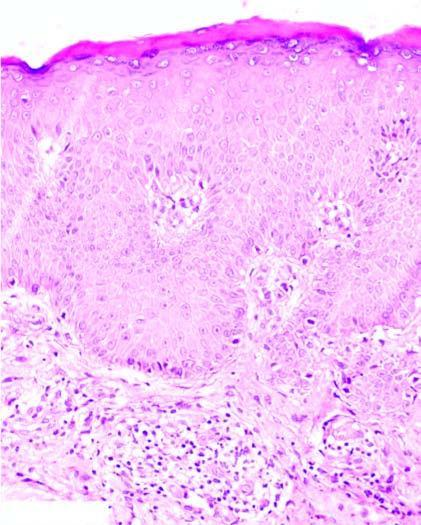does the dermis show mild perivascular chronic inflammatory cell infiltrate?
Answer the question using a single word or phrase. Yes 